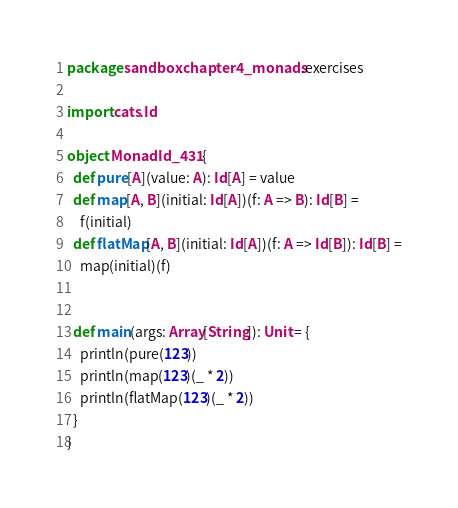Convert code to text. <code><loc_0><loc_0><loc_500><loc_500><_Scala_>package sandbox.chapter4_monads.exercises

import cats.Id

object MonadId_431 {
  def pure[A](value: A): Id[A] = value
  def map[A, B](initial: Id[A])(f: A => B): Id[B] =
    f(initial)
  def flatMap[A, B](initial: Id[A])(f: A => Id[B]): Id[B] =
    map(initial)(f)


  def main(args: Array[String]): Unit = {
    println(pure(123))
    println(map(123)(_ * 2))
    println(flatMap(123)(_ * 2))
  }
}
</code> 